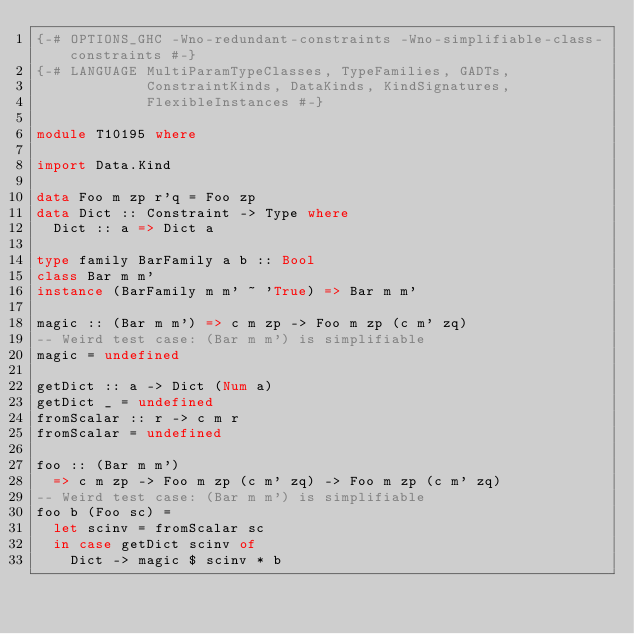Convert code to text. <code><loc_0><loc_0><loc_500><loc_500><_Haskell_>{-# OPTIONS_GHC -Wno-redundant-constraints -Wno-simplifiable-class-constraints #-}
{-# LANGUAGE MultiParamTypeClasses, TypeFamilies, GADTs,
             ConstraintKinds, DataKinds, KindSignatures,
             FlexibleInstances #-}

module T10195 where

import Data.Kind

data Foo m zp r'q = Foo zp
data Dict :: Constraint -> Type where
  Dict :: a => Dict a

type family BarFamily a b :: Bool
class Bar m m'
instance (BarFamily m m' ~ 'True) => Bar m m'

magic :: (Bar m m') => c m zp -> Foo m zp (c m' zq)
-- Weird test case: (Bar m m') is simplifiable
magic = undefined

getDict :: a -> Dict (Num a)
getDict _ = undefined
fromScalar :: r -> c m r
fromScalar = undefined

foo :: (Bar m m')
  => c m zp -> Foo m zp (c m' zq) -> Foo m zp (c m' zq)
-- Weird test case: (Bar m m') is simplifiable
foo b (Foo sc) =
  let scinv = fromScalar sc
  in case getDict scinv of
    Dict -> magic $ scinv * b
</code> 